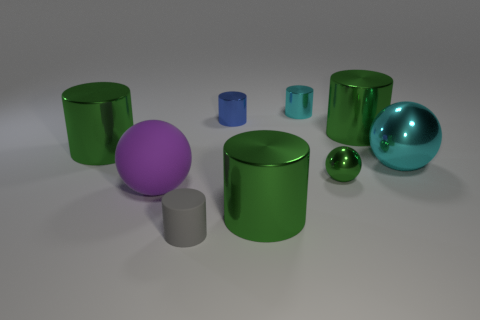How many green cylinders must be subtracted to get 1 green cylinders? 2 Subtract all cyan metallic balls. How many balls are left? 2 Subtract all blue spheres. How many green cylinders are left? 3 Subtract all green balls. How many balls are left? 2 Subtract 1 cylinders. How many cylinders are left? 5 Add 1 tiny metallic things. How many objects exist? 10 Add 4 purple balls. How many purple balls exist? 5 Subtract 0 red cubes. How many objects are left? 9 Subtract all cylinders. How many objects are left? 3 Subtract all green spheres. Subtract all blue cylinders. How many spheres are left? 2 